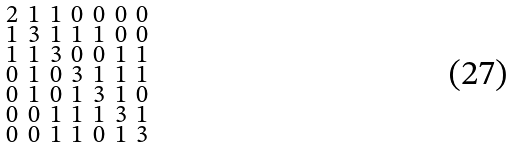<formula> <loc_0><loc_0><loc_500><loc_500>\begin{smallmatrix} 2 & 1 & 1 & 0 & 0 & 0 & 0 \\ 1 & 3 & 1 & 1 & 1 & 0 & 0 \\ 1 & 1 & 3 & 0 & 0 & 1 & 1 \\ 0 & 1 & 0 & 3 & 1 & 1 & 1 \\ 0 & 1 & 0 & 1 & 3 & 1 & 0 \\ 0 & 0 & 1 & 1 & 1 & 3 & 1 \\ 0 & 0 & 1 & 1 & 0 & 1 & 3 \end{smallmatrix}</formula> 